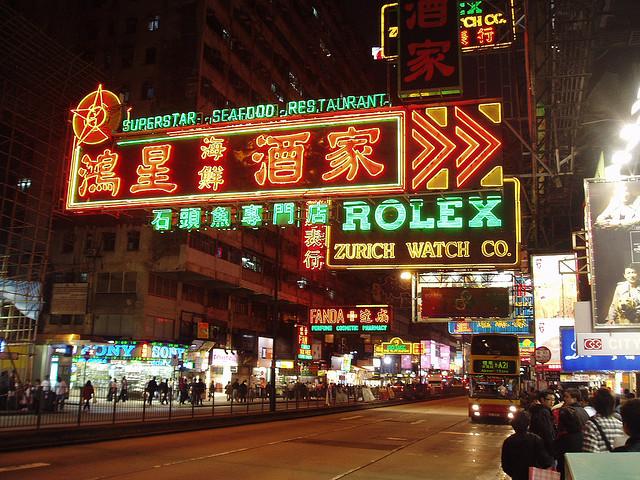What brand of watch is being advertised?
Keep it brief. Rolex. What is the sign pictured on the right advertising?
Keep it brief. Rolex. Is this in London?
Concise answer only. No. Is it day time?
Keep it brief. No. 